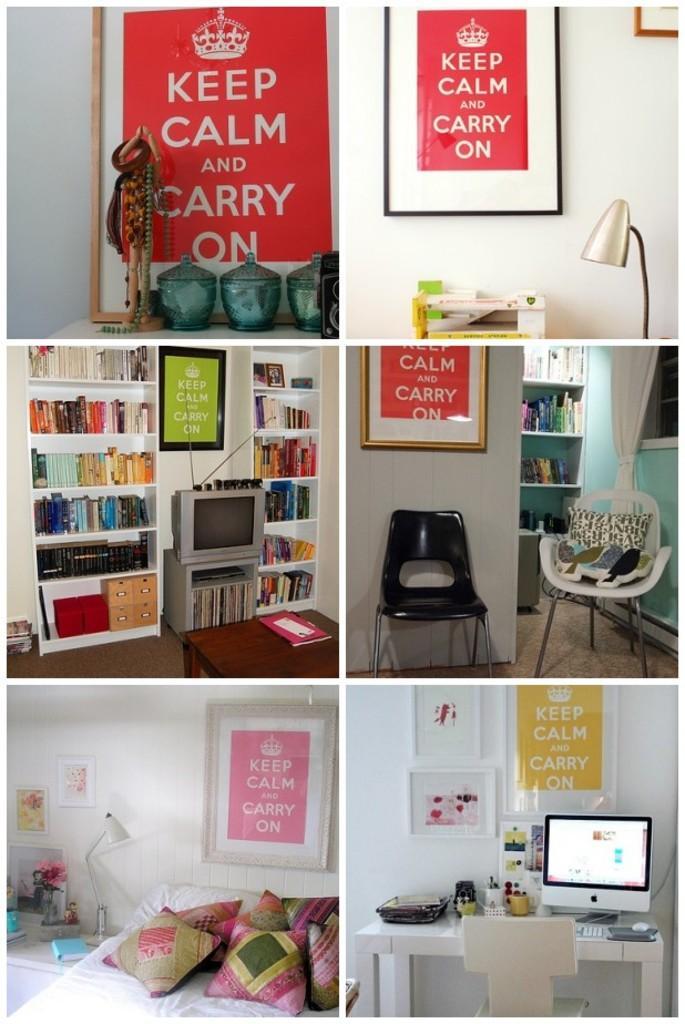Describe this image in one or two sentences. As we can see in the image there is a white color wall, lamp, photo frame, shelves, chair, bed , screen and pillows. 